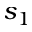<formula> <loc_0><loc_0><loc_500><loc_500>s _ { 1 }</formula> 